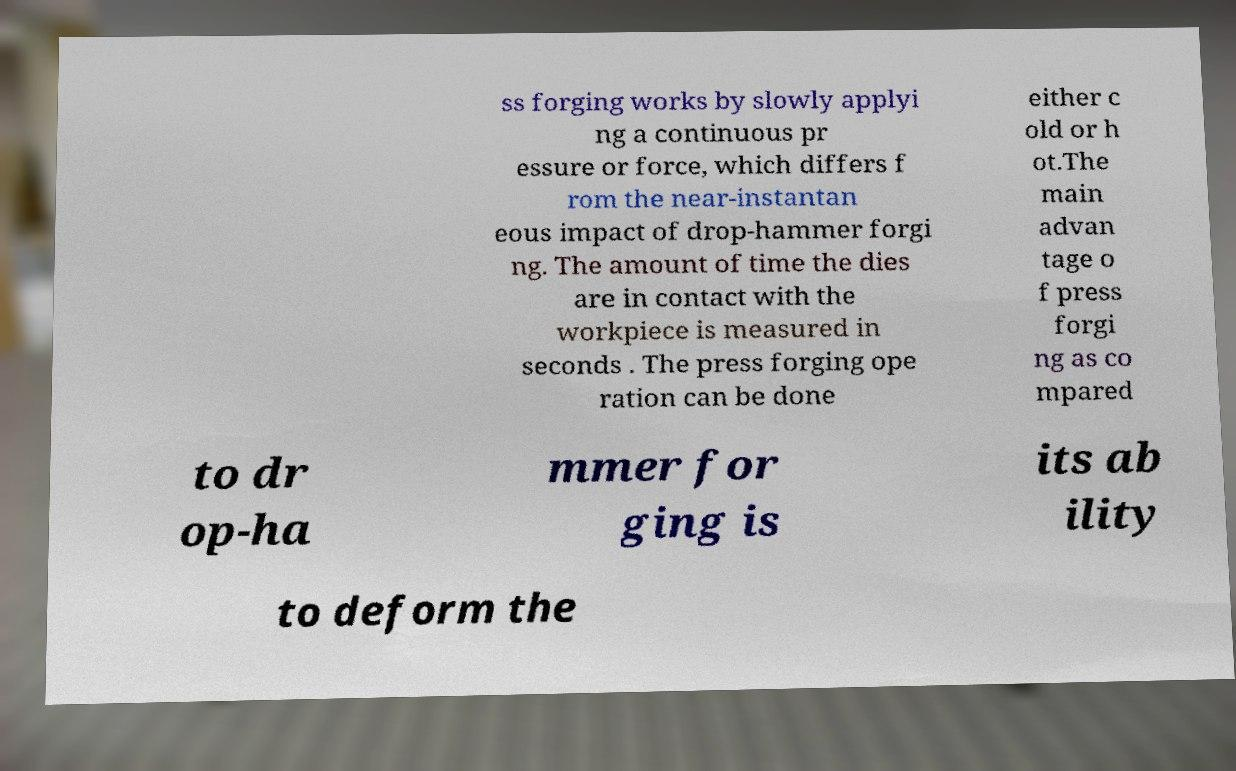There's text embedded in this image that I need extracted. Can you transcribe it verbatim? ss forging works by slowly applyi ng a continuous pr essure or force, which differs f rom the near-instantan eous impact of drop-hammer forgi ng. The amount of time the dies are in contact with the workpiece is measured in seconds . The press forging ope ration can be done either c old or h ot.The main advan tage o f press forgi ng as co mpared to dr op-ha mmer for ging is its ab ility to deform the 